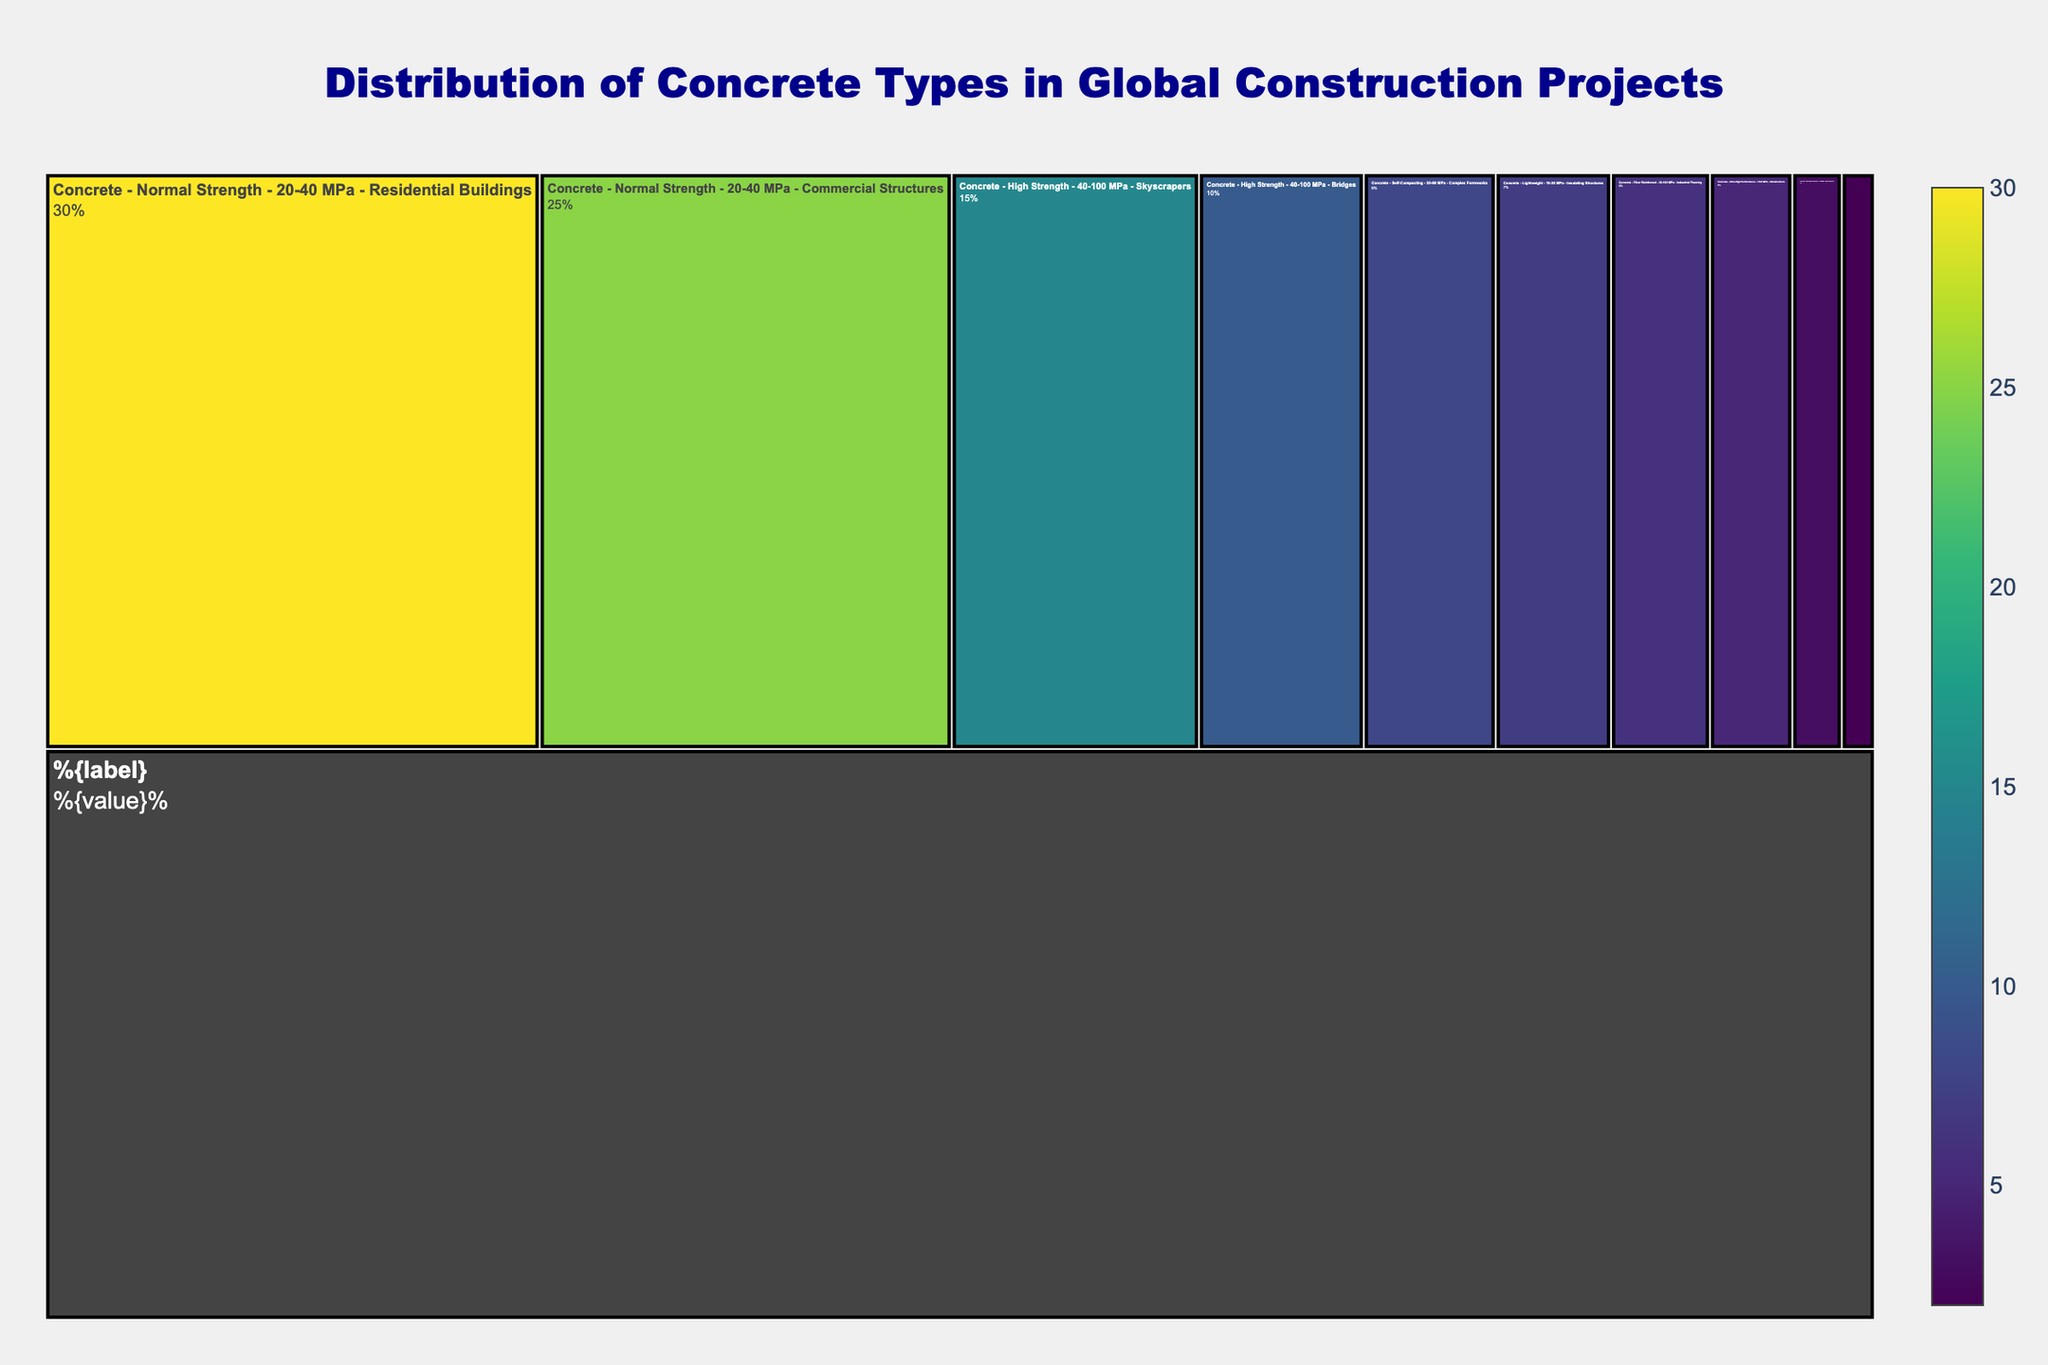What is the title of the Icicle chart? The title is prominently displayed at the top of the chart. By looking at the top section of the figure, we can see it.
Answer: Distribution of Concrete Types in Global Construction Projects Which concrete type has the highest usage in residential buildings? To find this, look at the subsection under "Concrete" and then "Normal Strength" which branches out into different applications. The residential buildings section shows the usage percentage.
Answer: Normal Strength How much more is the usage percentage of normal strength concrete in commercial structures than in special projects? First, locate the usage percentage of normal strength concrete in commercial structures (25%) and then the usage of ultra-high performance concrete in special projects (3%). The difference is calculated by subtracting the smaller percentage from the larger one.
Answer: 22% Which application uses the highest percentage of high strength concrete? Locate the sections under "High Strength" and compare the usage percentages of "Skyscrapers" and "Bridges". The Skyscraper section shows the highest usage percentage.
Answer: Skyscrapers What is the combined usage percentage of lightweight and heavyweight concrete? Identify the usage percentages for both lightweight (7%) and heavyweight (2%) concrete, then sum these values.
Answer: 9% Compare the usage percentages of ultra-high performance concrete in infrastructure and normal strength concrete in commercial structures. Which is higher? Look at the percentage values for ultra-high performance concrete in infrastructure (5%) and normal strength concrete in commercial structures (25%). The commercial structures section has the higher value.
Answer: Normal Strength in Commercial Structures Which application has the lowest usage percentage among all the categories? Examine all the applications listed under each type of concrete. The application with the smallest percentage (2%) appears under heavyweight concrete.
Answer: Radiation Shielding What is the usage percentage of fiber reinforced concrete? Locate the section under "Fiber Reinforced" concrete and identify the value. The figure shows the percentage as 6%.
Answer: 6% How is the distribution of high strength concrete split between skyscrapers and bridges? Look at the sections under "High Strength" concrete and note the percentages for skyscrapers (15%) and bridges (10%). Summing these verifies the total for high strength concrete.
Answer: 15% for Skyscrapers, 10% for Bridges What is the combined usage percentage of self-compacting and fiber reinforced concrete? Add the usage percentages for self-compacting (8%) and fiber reinforced (6%) concrete. The total is found by summing these values.
Answer: 14% 